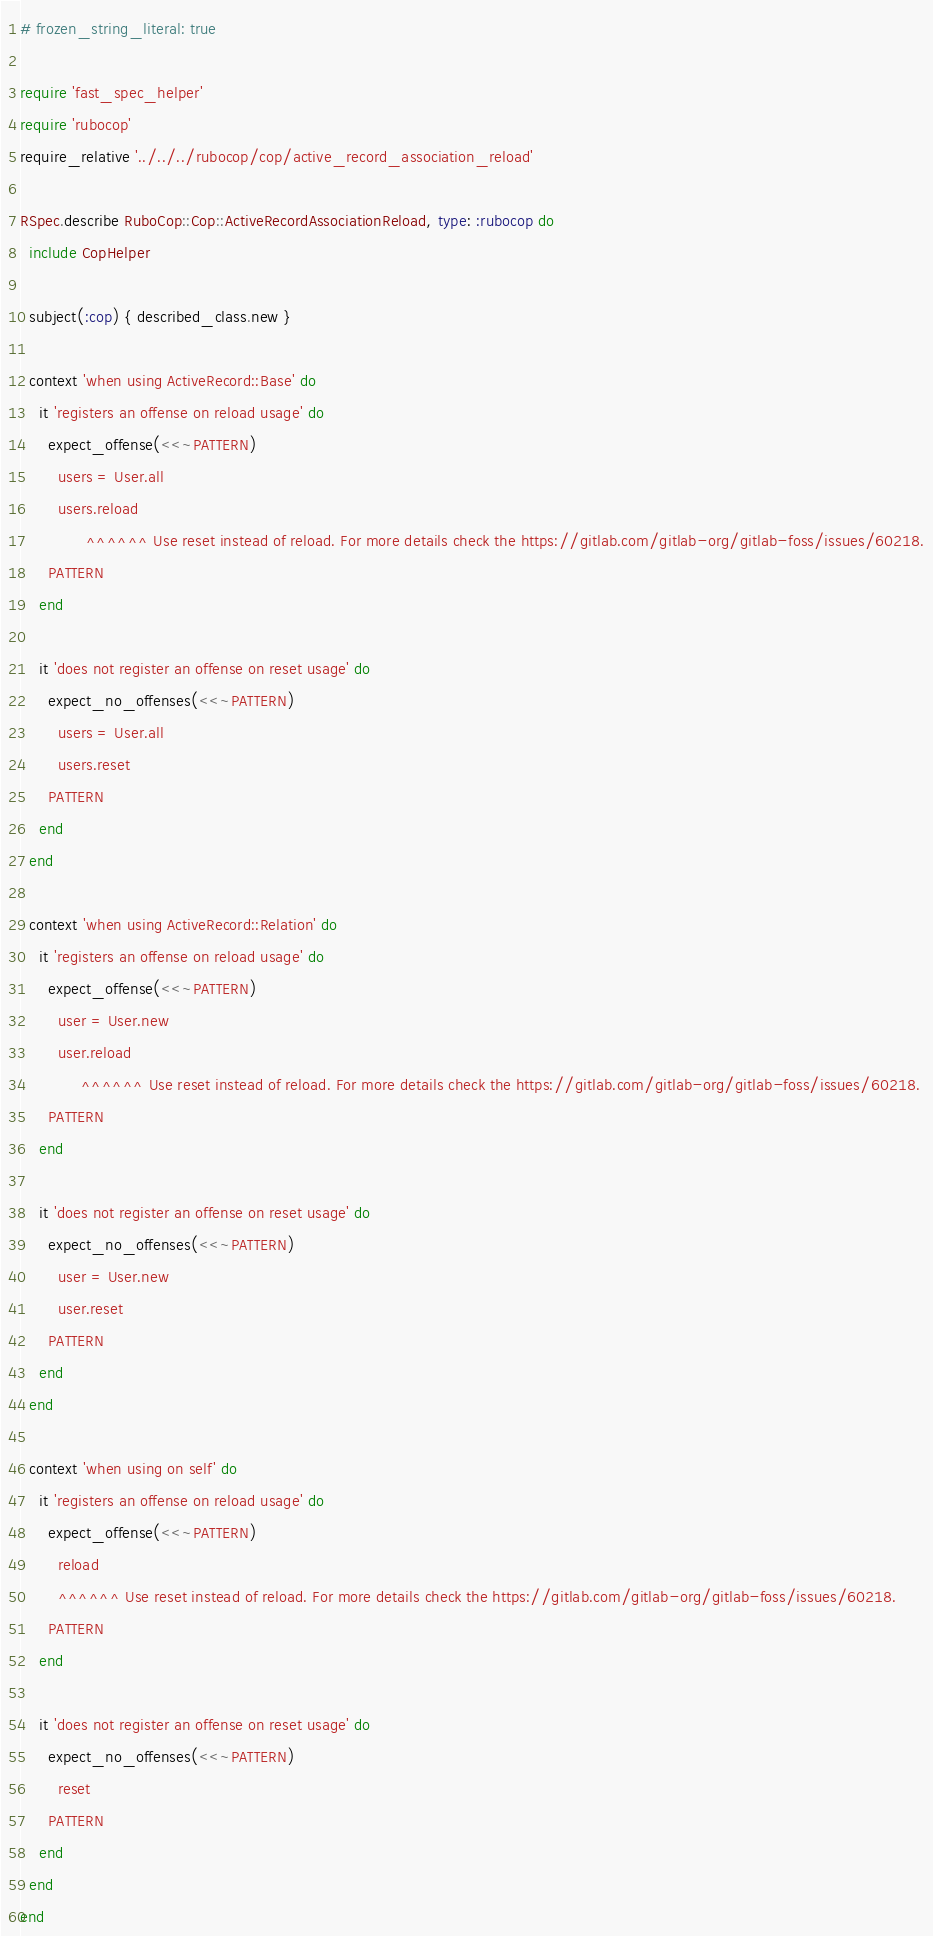<code> <loc_0><loc_0><loc_500><loc_500><_Ruby_># frozen_string_literal: true

require 'fast_spec_helper'
require 'rubocop'
require_relative '../../../rubocop/cop/active_record_association_reload'

RSpec.describe RuboCop::Cop::ActiveRecordAssociationReload, type: :rubocop do
  include CopHelper

  subject(:cop) { described_class.new }

  context 'when using ActiveRecord::Base' do
    it 'registers an offense on reload usage' do
      expect_offense(<<~PATTERN)
        users = User.all
        users.reload
              ^^^^^^ Use reset instead of reload. For more details check the https://gitlab.com/gitlab-org/gitlab-foss/issues/60218.
      PATTERN
    end

    it 'does not register an offense on reset usage' do
      expect_no_offenses(<<~PATTERN)
        users = User.all
        users.reset
      PATTERN
    end
  end

  context 'when using ActiveRecord::Relation' do
    it 'registers an offense on reload usage' do
      expect_offense(<<~PATTERN)
        user = User.new
        user.reload
             ^^^^^^ Use reset instead of reload. For more details check the https://gitlab.com/gitlab-org/gitlab-foss/issues/60218.
      PATTERN
    end

    it 'does not register an offense on reset usage' do
      expect_no_offenses(<<~PATTERN)
        user = User.new
        user.reset
      PATTERN
    end
  end

  context 'when using on self' do
    it 'registers an offense on reload usage' do
      expect_offense(<<~PATTERN)
        reload
        ^^^^^^ Use reset instead of reload. For more details check the https://gitlab.com/gitlab-org/gitlab-foss/issues/60218.
      PATTERN
    end

    it 'does not register an offense on reset usage' do
      expect_no_offenses(<<~PATTERN)
        reset
      PATTERN
    end
  end
end
</code> 